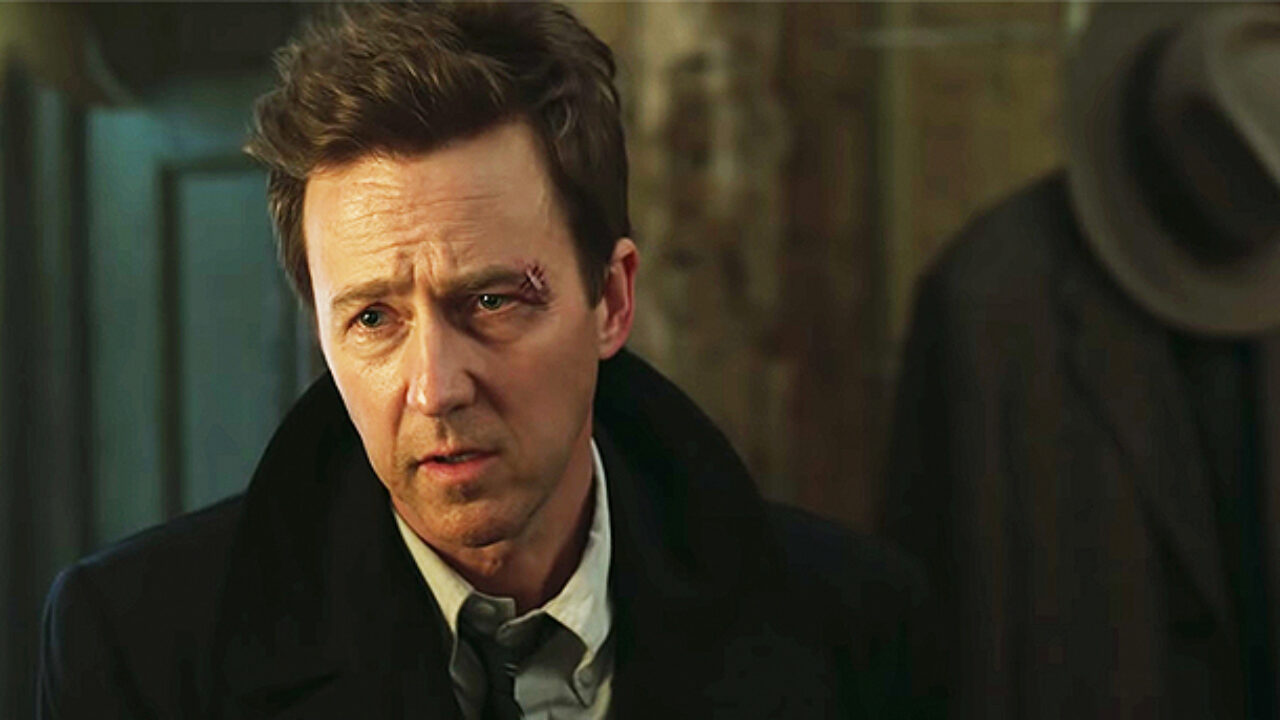What's happening in the scene? In this image, we see an individual who appears to be the central focus of the frame. He is dressed in a formal black suit and tie but his hair is styled in a somewhat disheveled manner. The individual's face shows a look of deep concern, contributing to an intriguing and tense atmosphere. The backdrop of the setting is a dimly lit room, with a hat rack visible to the right. This composition suggests a dramatic moment, likely a still from an intense scene in a film or movie. 